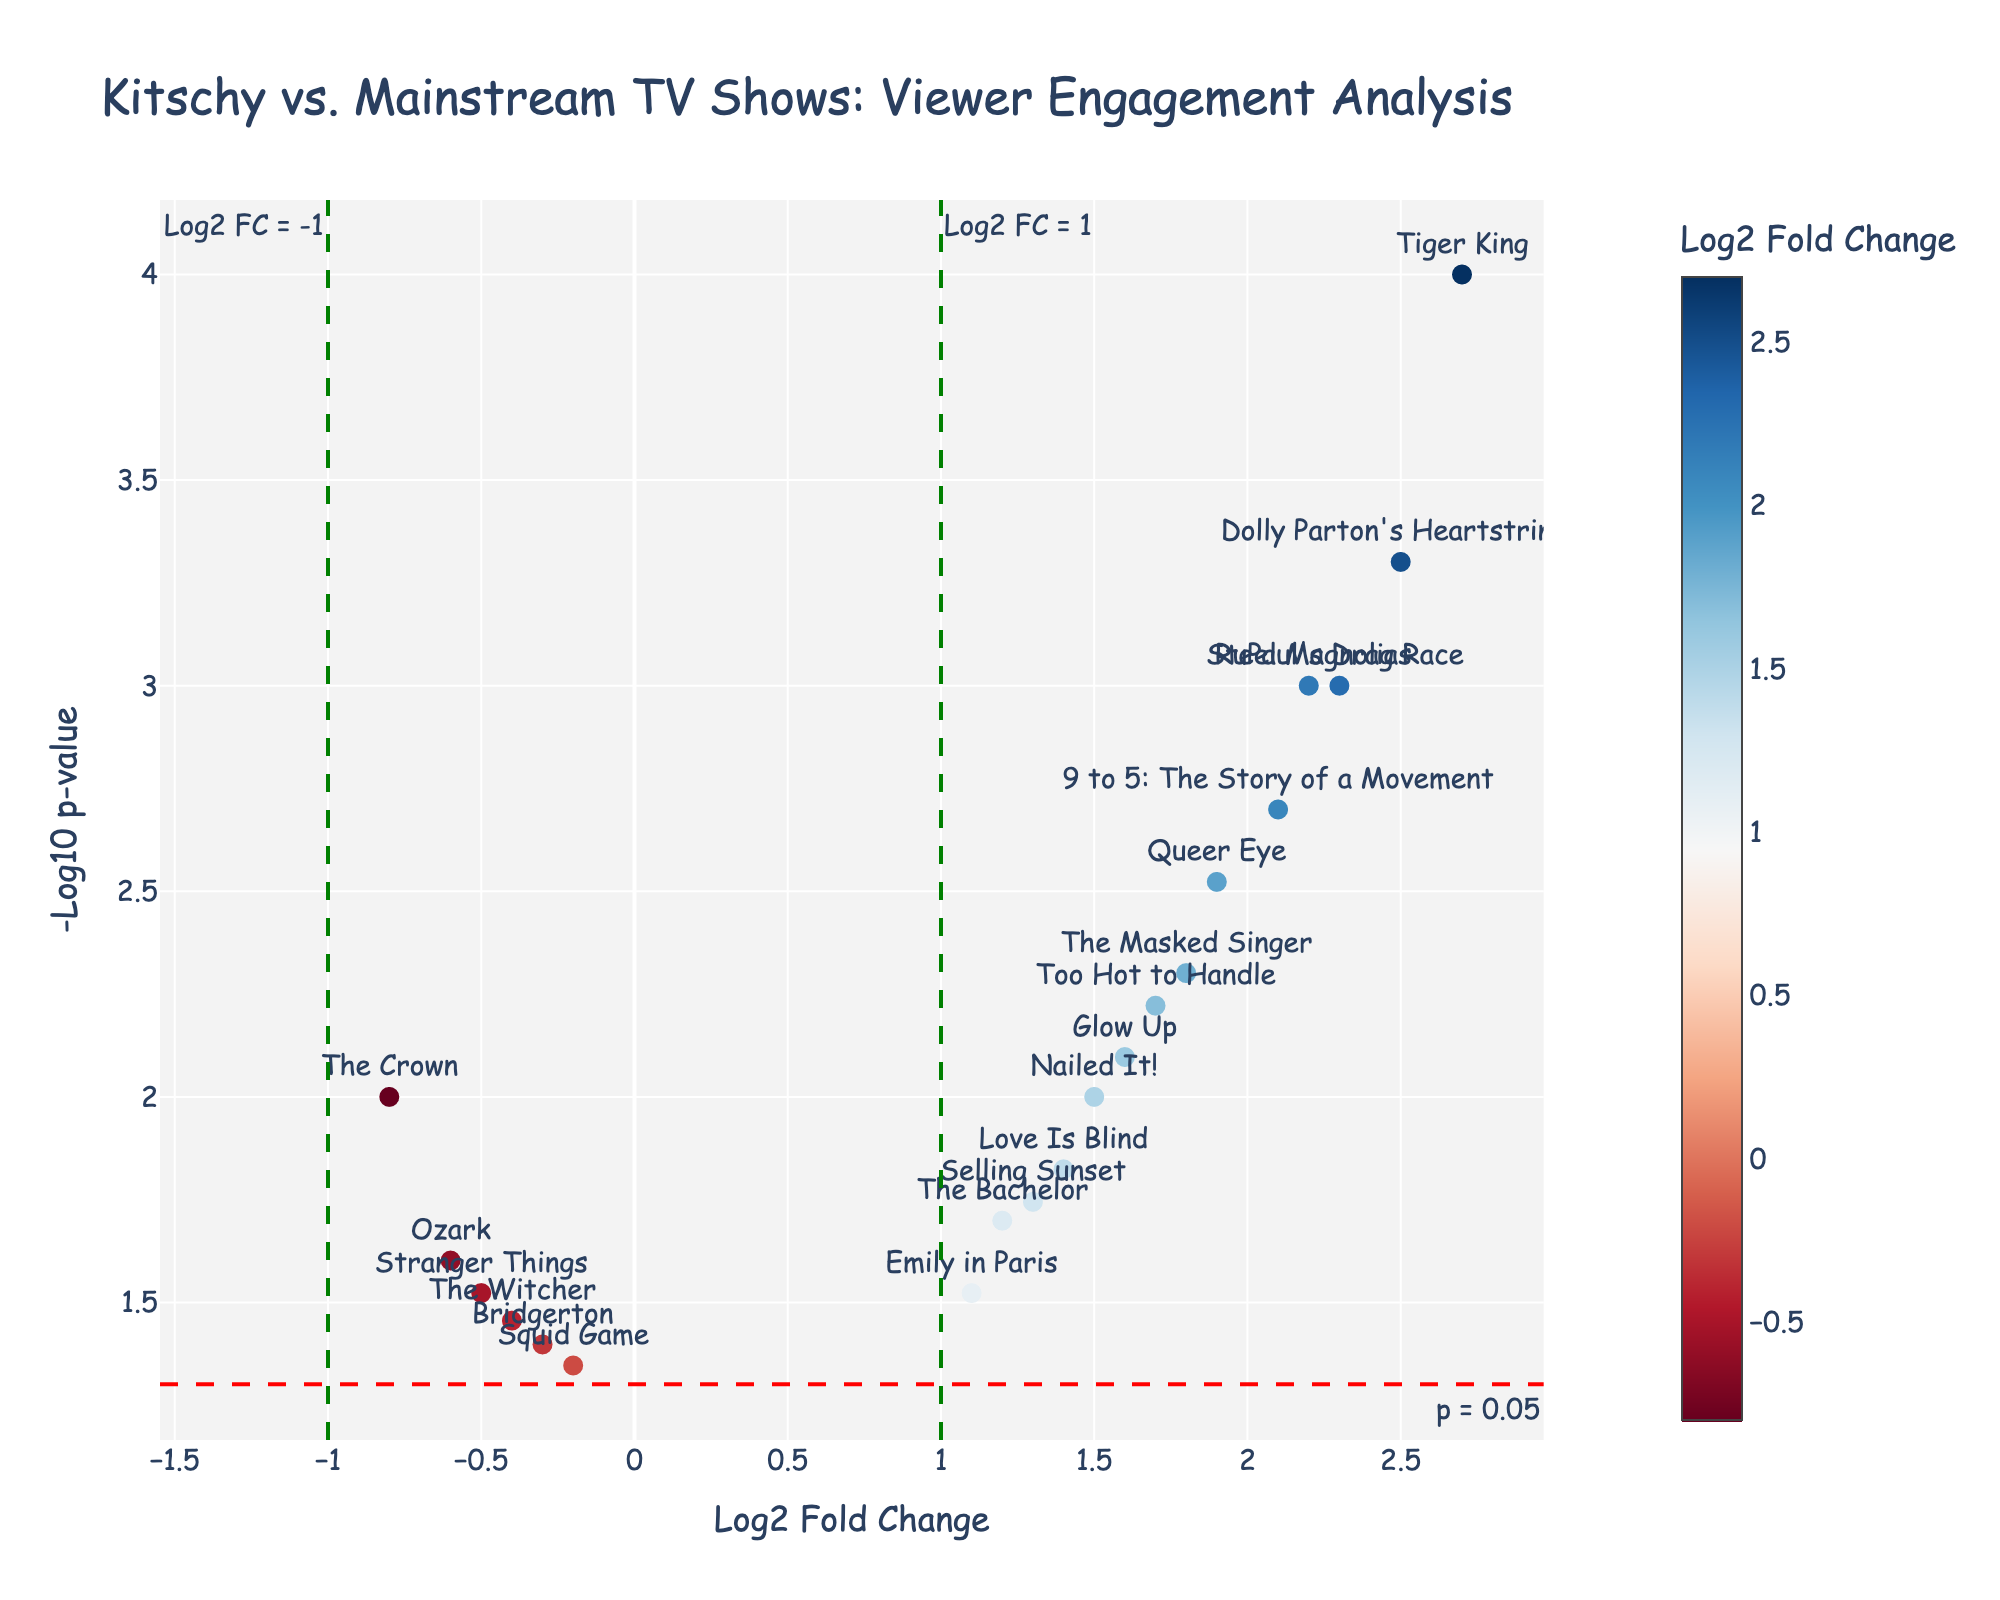What is the title of the plot? The title of the plot is located at the top of the figure in a larger font size. It summarizes the content of the plot.
Answer: Kitschy vs. Mainstream TV Shows: Viewer Engagement Analysis Which show has the highest log2 fold change? Look at the x-axis (Log2 Fold Change) and find the data point farthest to the right. The show's name will be labeled near this point.
Answer: Tiger King How many shows have p-values below 0.01? The y-axis represents -Log10 p-value. P-values below 0.01 translate to -Log10(p) above 2. Locate the points above y=2.
Answer: 10 Which show is marked at the exact threshold of Log2 FC = 1? Look at the green dashed line on the figure representing Log2 FC = 1. Find the point that lies directly on this line.
Answer: The Bachelor How does "RuPaul's Drag Race" compare to "Dolly Parton's Heartstrings" in terms of log2 fold change and p-value? Find both shows on the plot and compare their x and y positions. "RuPaul's Drag Race" is at 2.3 Log2 FC and -Log10(0.001), while "Dolly Parton's Heartstrings" is at 2.5 Log2 FC and -Log10(0.0005). "Dolly Parton's Heartstrings" has a higher Log2 FC and lower p-value.
Answer: Dolly Parton's Heartstrings has a higher Log2 FC and lower p-value What does the red dashed horizontal line represent? The red dashed line is placed horizontally at a specific position on the y-axis. The annotation /label next to it explains its significance.
Answer: p = 0.05 Which shows have negative log2 fold changes and how many of them are there? Look at the left side of the x-axis (negative values). Count the data points labeled with show names in this region.
Answer: 5 Is "Stranger Things" considered significant based on the p-value? Significant p-values are generally below 0.05. Locate "Stranger Things" and check if it is above or below the red dashed horizontal line.
Answer: No What threshold values are highlighted by the green vertical lines and what do they signify? Look for the green dashed vertical lines and read the annotations next to them. These lines highlight specific Log2 Fold Change values.
Answer: Log2 FC = 1 and Log2 FC = -1 How does the viewer engagement in "The Crown" compare to the overall average fold change? Find "The Crown" on the plot. Calculate the average Log2 Fold Change by adding all values and dividing by the number of shows, then compare this to the position of "The Crown". "The Crown" has -0.8 Log2 FC. Average Log2 FC = (sum of all Log2 FC values) / (total number of shows). The comparison reveals if "The Crown"'s engagement is above or below the average.
Answer: The Crown's engagement is below the overall average Log2 FC 